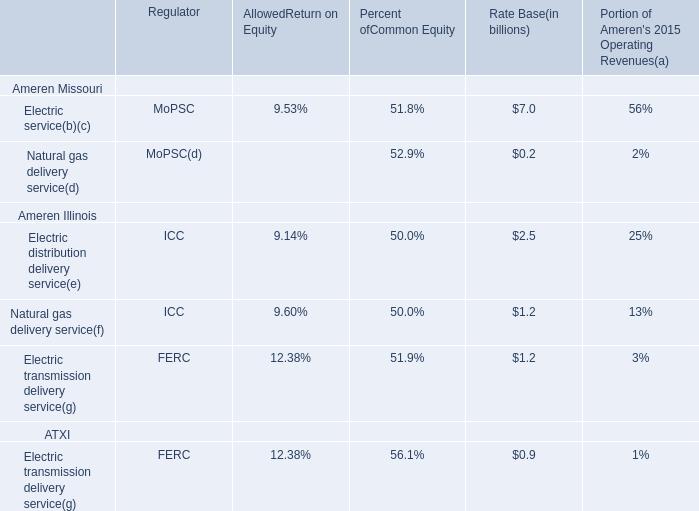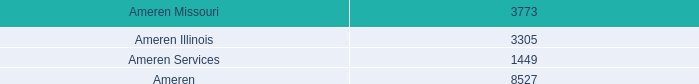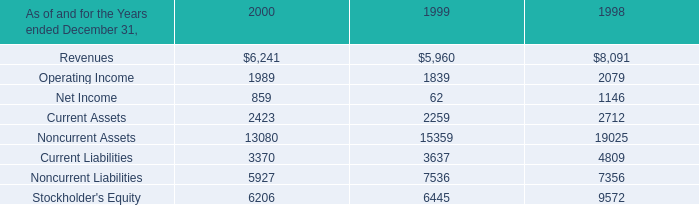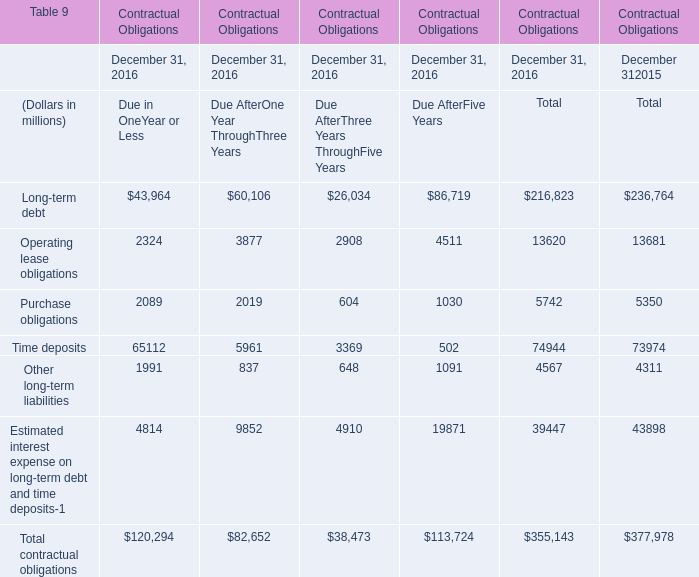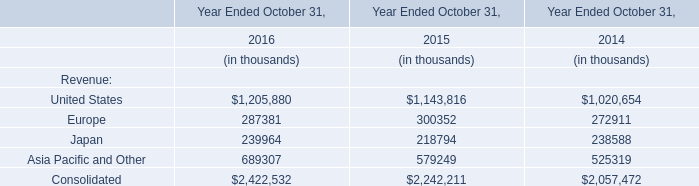what was the implied value of the preferred shares of eletropaulo based on the bndes acquisition , in billions? 
Computations: (1 / 59%)
Answer: 1.69492. 